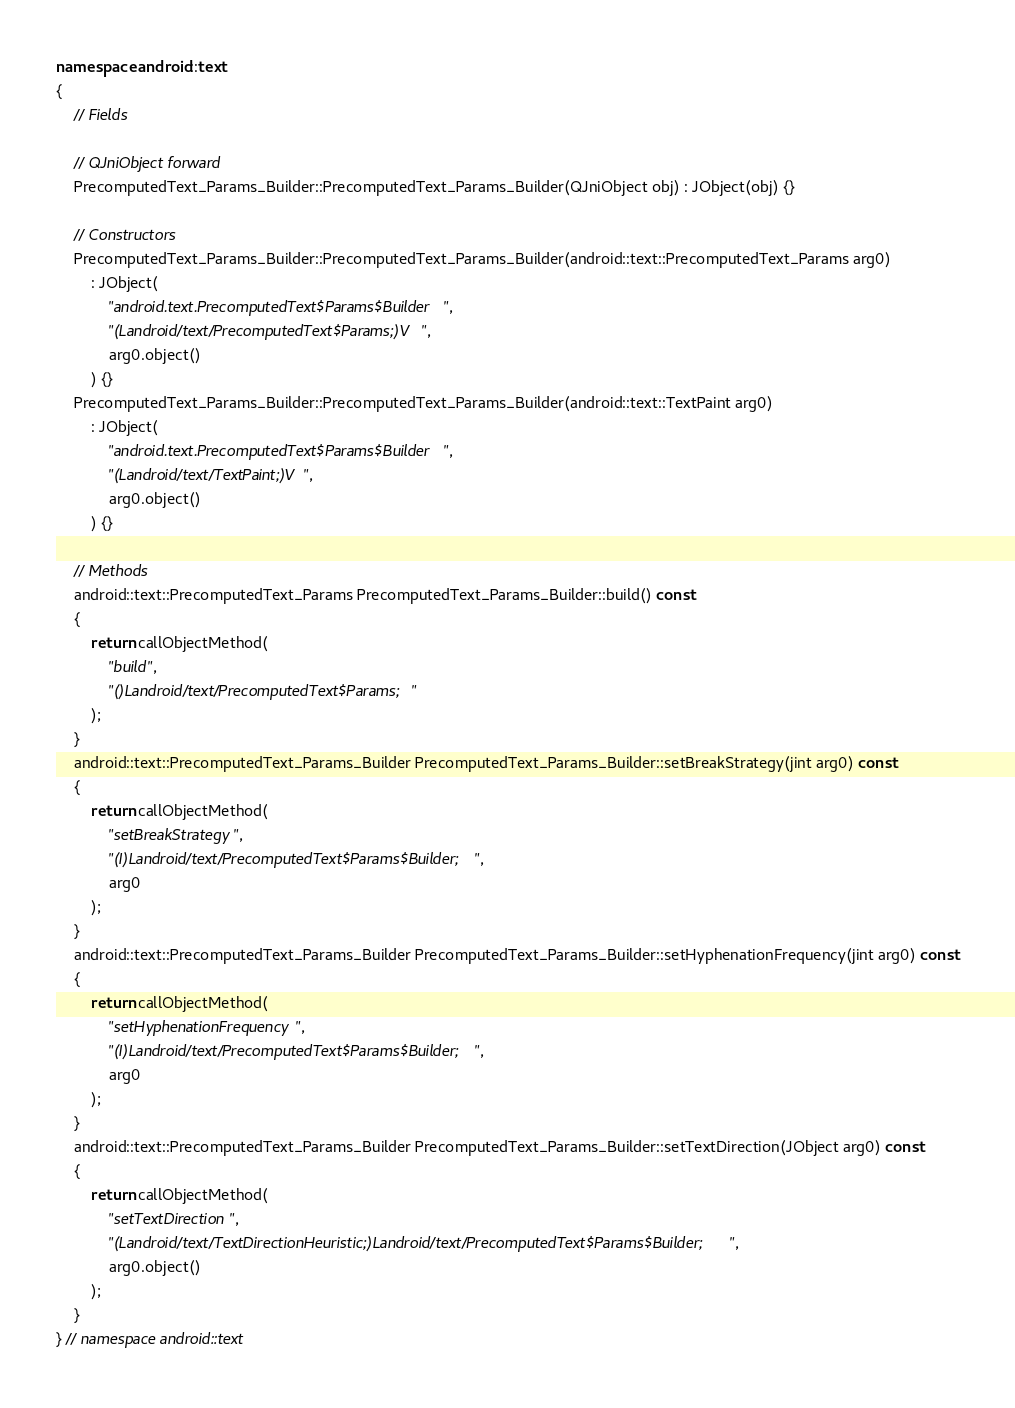<code> <loc_0><loc_0><loc_500><loc_500><_C++_>
namespace android::text
{
	// Fields
	
	// QJniObject forward
	PrecomputedText_Params_Builder::PrecomputedText_Params_Builder(QJniObject obj) : JObject(obj) {}
	
	// Constructors
	PrecomputedText_Params_Builder::PrecomputedText_Params_Builder(android::text::PrecomputedText_Params arg0)
		: JObject(
			"android.text.PrecomputedText$Params$Builder",
			"(Landroid/text/PrecomputedText$Params;)V",
			arg0.object()
		) {}
	PrecomputedText_Params_Builder::PrecomputedText_Params_Builder(android::text::TextPaint arg0)
		: JObject(
			"android.text.PrecomputedText$Params$Builder",
			"(Landroid/text/TextPaint;)V",
			arg0.object()
		) {}
	
	// Methods
	android::text::PrecomputedText_Params PrecomputedText_Params_Builder::build() const
	{
		return callObjectMethod(
			"build",
			"()Landroid/text/PrecomputedText$Params;"
		);
	}
	android::text::PrecomputedText_Params_Builder PrecomputedText_Params_Builder::setBreakStrategy(jint arg0) const
	{
		return callObjectMethod(
			"setBreakStrategy",
			"(I)Landroid/text/PrecomputedText$Params$Builder;",
			arg0
		);
	}
	android::text::PrecomputedText_Params_Builder PrecomputedText_Params_Builder::setHyphenationFrequency(jint arg0) const
	{
		return callObjectMethod(
			"setHyphenationFrequency",
			"(I)Landroid/text/PrecomputedText$Params$Builder;",
			arg0
		);
	}
	android::text::PrecomputedText_Params_Builder PrecomputedText_Params_Builder::setTextDirection(JObject arg0) const
	{
		return callObjectMethod(
			"setTextDirection",
			"(Landroid/text/TextDirectionHeuristic;)Landroid/text/PrecomputedText$Params$Builder;",
			arg0.object()
		);
	}
} // namespace android::text

</code> 